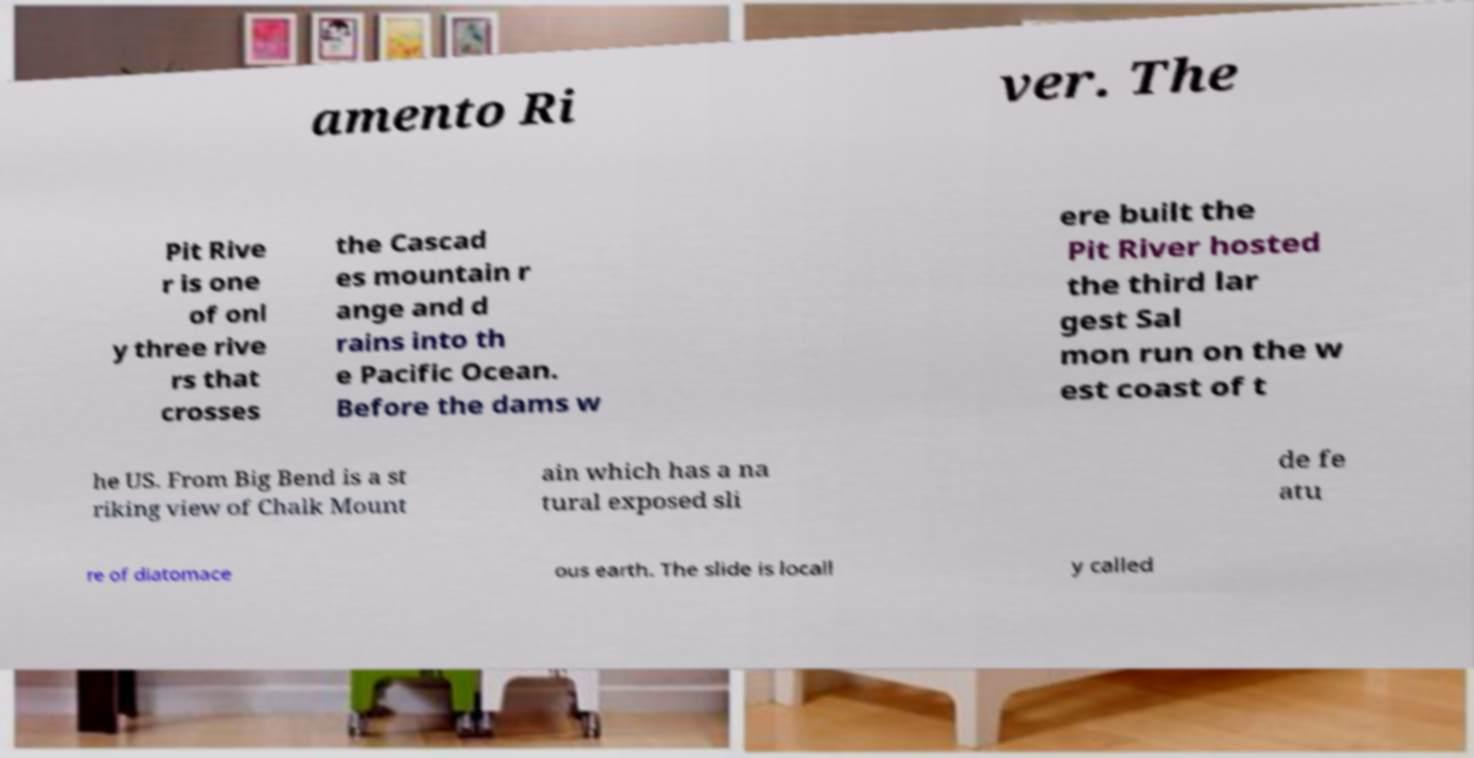For documentation purposes, I need the text within this image transcribed. Could you provide that? amento Ri ver. The Pit Rive r is one of onl y three rive rs that crosses the Cascad es mountain r ange and d rains into th e Pacific Ocean. Before the dams w ere built the Pit River hosted the third lar gest Sal mon run on the w est coast of t he US. From Big Bend is a st riking view of Chalk Mount ain which has a na tural exposed sli de fe atu re of diatomace ous earth. The slide is locall y called 